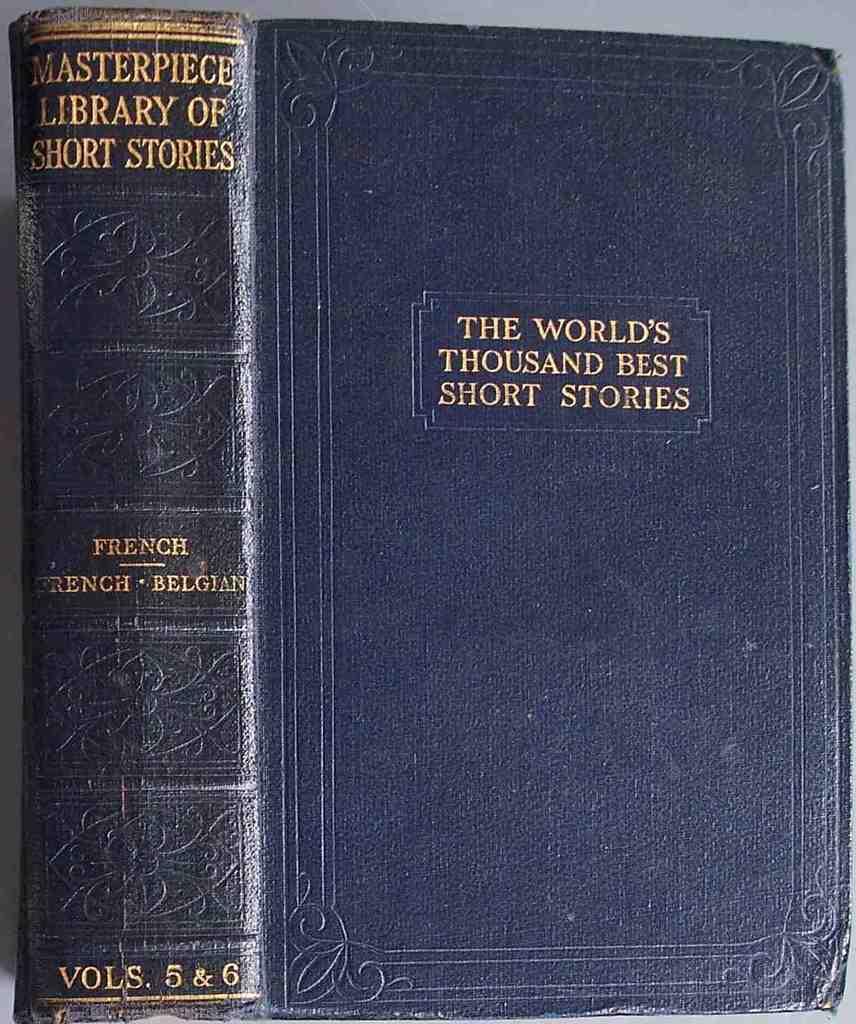What is the title of the book?
Ensure brevity in your answer.  The world's thousand best short stories. What volume is this book?
Provide a short and direct response. 5 & 6. 